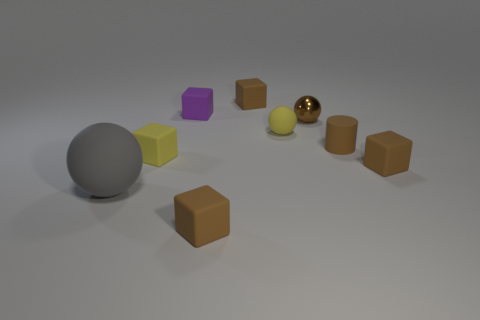Subtract all rubber spheres. How many spheres are left? 1 Add 1 spheres. How many objects exist? 10 Subtract all yellow balls. How many balls are left? 2 Subtract 1 blocks. How many blocks are left? 4 Subtract all tiny yellow shiny objects. Subtract all brown balls. How many objects are left? 8 Add 6 cylinders. How many cylinders are left? 7 Add 5 rubber blocks. How many rubber blocks exist? 10 Subtract 0 red cylinders. How many objects are left? 9 Subtract all blocks. How many objects are left? 4 Subtract all purple balls. Subtract all green cylinders. How many balls are left? 3 